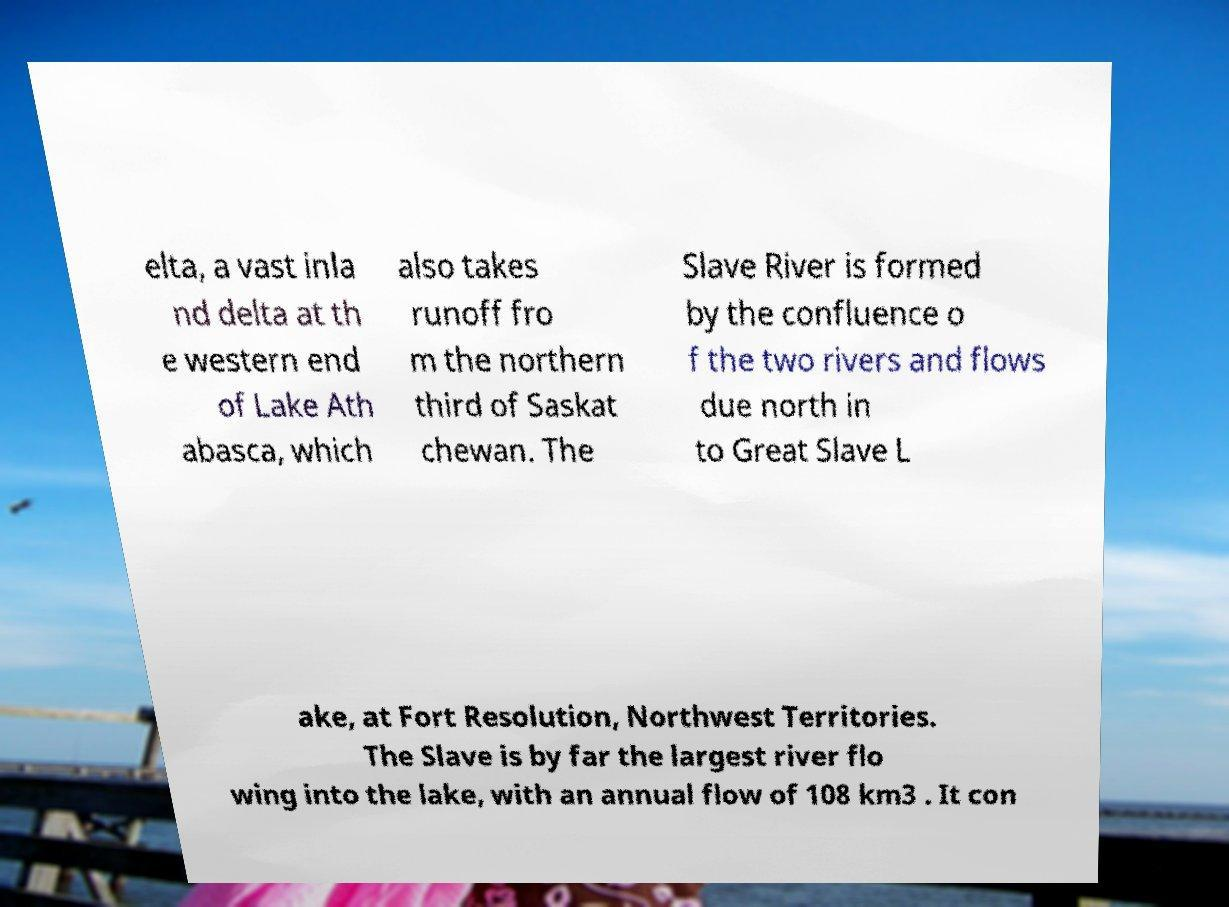Please identify and transcribe the text found in this image. elta, a vast inla nd delta at th e western end of Lake Ath abasca, which also takes runoff fro m the northern third of Saskat chewan. The Slave River is formed by the confluence o f the two rivers and flows due north in to Great Slave L ake, at Fort Resolution, Northwest Territories. The Slave is by far the largest river flo wing into the lake, with an annual flow of 108 km3 . It con 